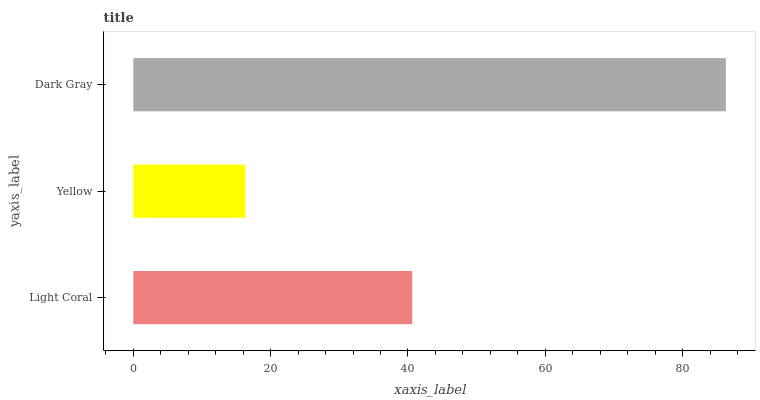Is Yellow the minimum?
Answer yes or no. Yes. Is Dark Gray the maximum?
Answer yes or no. Yes. Is Dark Gray the minimum?
Answer yes or no. No. Is Yellow the maximum?
Answer yes or no. No. Is Dark Gray greater than Yellow?
Answer yes or no. Yes. Is Yellow less than Dark Gray?
Answer yes or no. Yes. Is Yellow greater than Dark Gray?
Answer yes or no. No. Is Dark Gray less than Yellow?
Answer yes or no. No. Is Light Coral the high median?
Answer yes or no. Yes. Is Light Coral the low median?
Answer yes or no. Yes. Is Yellow the high median?
Answer yes or no. No. Is Yellow the low median?
Answer yes or no. No. 